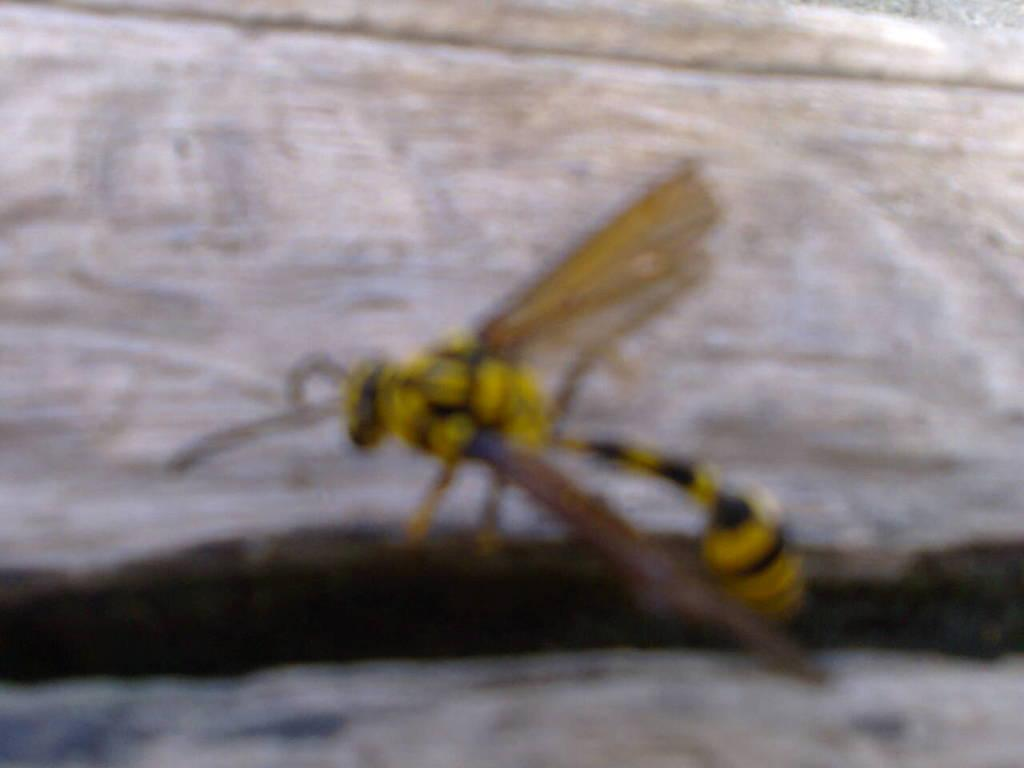What type of insect is present in the image? There is a dragonfly in the image. What is the dragonfly resting on or attached to in the image? The dragonfly is on an object in the image. What type of drain is visible in the image? There is no drain present in the image; it features a dragonfly on an object. Is the dragonfly in jail in the image? There is no jail or any indication of confinement in the image; it simply shows a dragonfly on an object. 